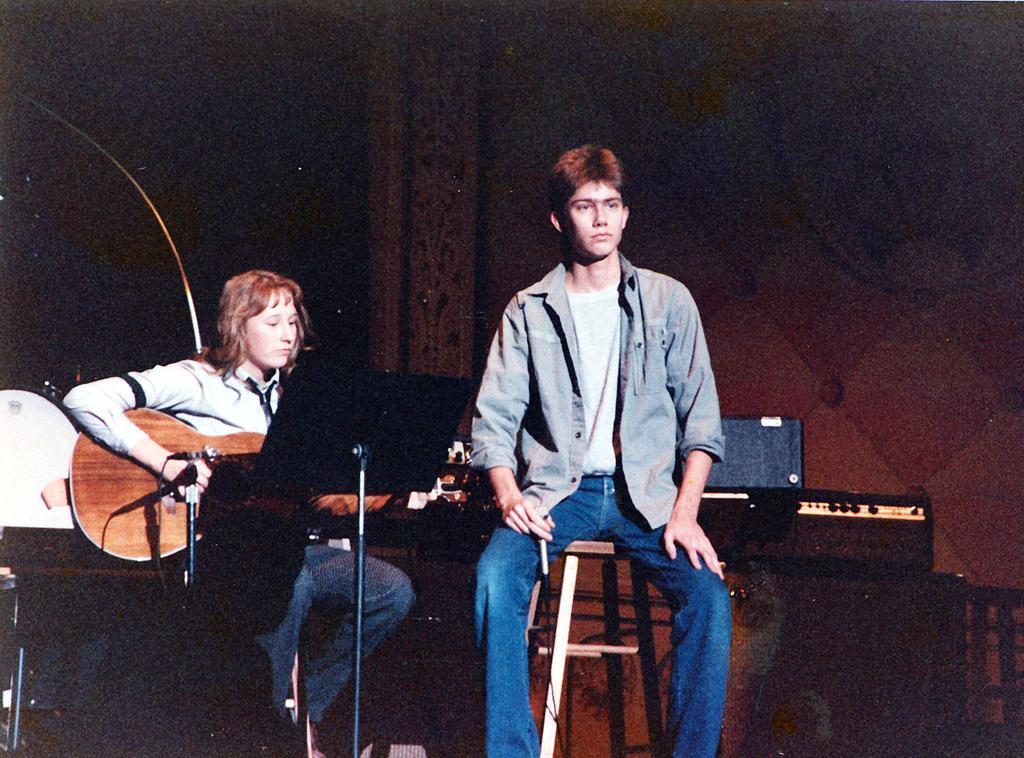Could you give a brief overview of what you see in this image? In this image there is a man sitting in a chair ,another woman sitting and playing a guitar ,and at the background there is a wall, drums some brief cases. 